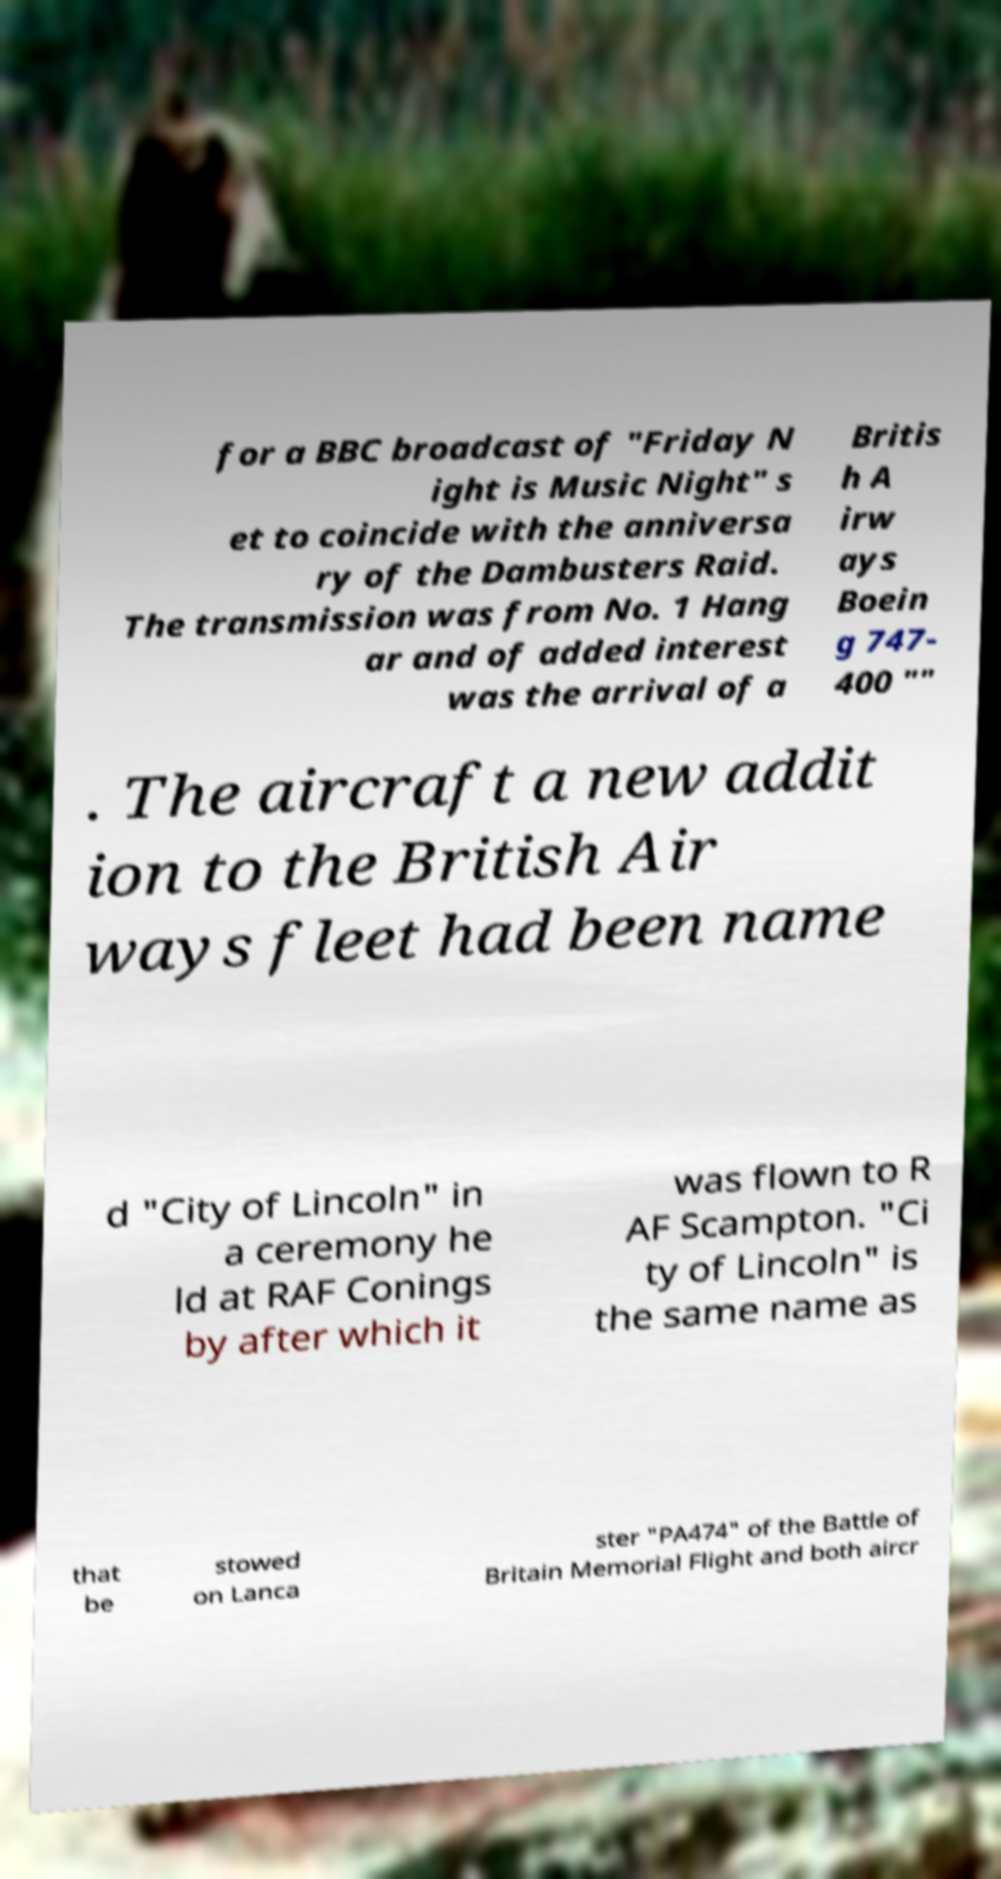Please identify and transcribe the text found in this image. for a BBC broadcast of "Friday N ight is Music Night" s et to coincide with the anniversa ry of the Dambusters Raid. The transmission was from No. 1 Hang ar and of added interest was the arrival of a Britis h A irw ays Boein g 747- 400 "" . The aircraft a new addit ion to the British Air ways fleet had been name d "City of Lincoln" in a ceremony he ld at RAF Conings by after which it was flown to R AF Scampton. "Ci ty of Lincoln" is the same name as that be stowed on Lanca ster "PA474" of the Battle of Britain Memorial Flight and both aircr 